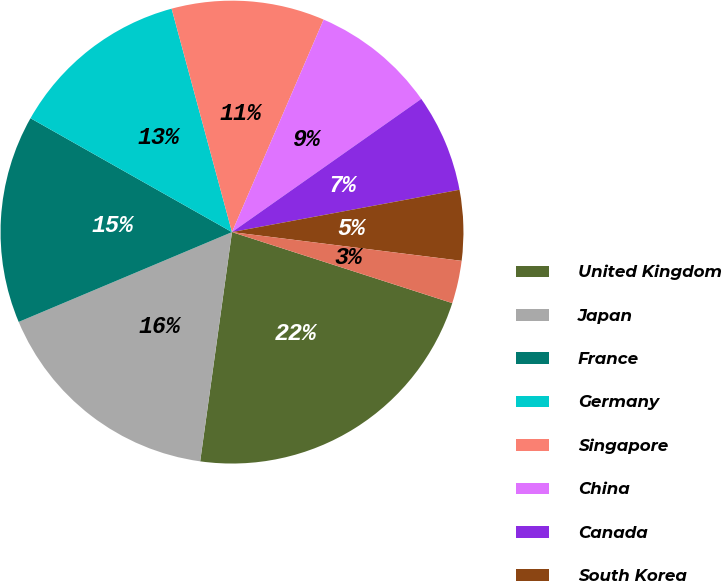Convert chart. <chart><loc_0><loc_0><loc_500><loc_500><pie_chart><fcel>United Kingdom<fcel>Japan<fcel>France<fcel>Germany<fcel>Singapore<fcel>China<fcel>Canada<fcel>South Korea<fcel>Ireland<nl><fcel>22.23%<fcel>16.46%<fcel>14.53%<fcel>12.61%<fcel>10.68%<fcel>8.76%<fcel>6.83%<fcel>4.91%<fcel>2.98%<nl></chart> 